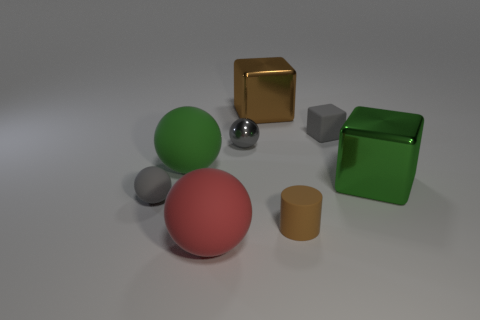There is a rubber cylinder; is its size the same as the gray ball that is on the left side of the big green matte ball?
Your response must be concise. Yes. What number of metal objects are red things or brown objects?
Your answer should be very brief. 1. Are there more tiny gray blocks than purple cubes?
Offer a terse response. Yes. The sphere that is the same color as the small shiny object is what size?
Offer a very short reply. Small. The gray matte thing that is right of the small thing that is left of the green rubber object is what shape?
Provide a short and direct response. Cube. There is a large ball that is in front of the tiny gray rubber thing on the left side of the metal ball; is there a gray thing in front of it?
Offer a terse response. No. There is a matte object that is the same size as the red matte ball; what color is it?
Your response must be concise. Green. There is a small thing that is in front of the metallic sphere and on the left side of the brown matte object; what shape is it?
Provide a short and direct response. Sphere. There is a green thing behind the metallic thing right of the brown block; how big is it?
Your response must be concise. Large. What number of other small rubber cylinders have the same color as the tiny cylinder?
Your answer should be compact. 0. 